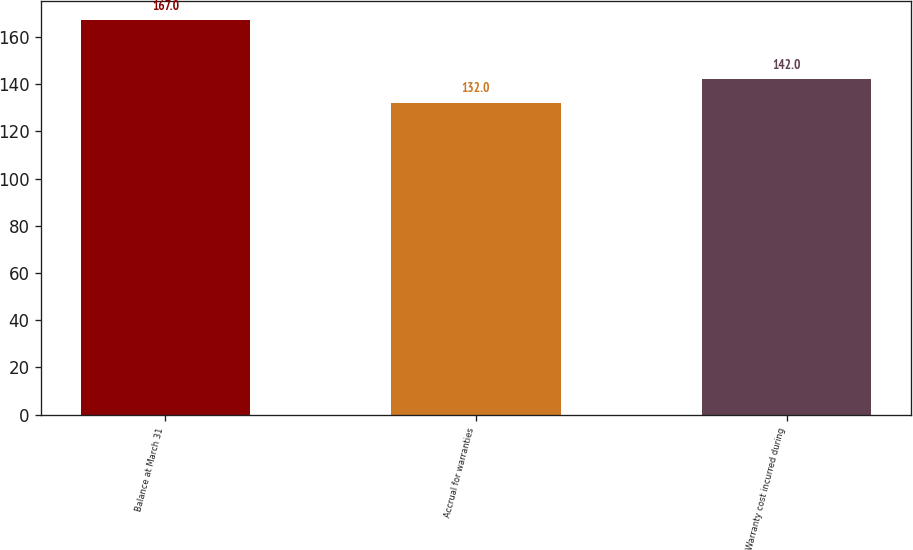<chart> <loc_0><loc_0><loc_500><loc_500><bar_chart><fcel>Balance at March 31<fcel>Accrual for warranties<fcel>Warranty cost incurred during<nl><fcel>167<fcel>132<fcel>142<nl></chart> 